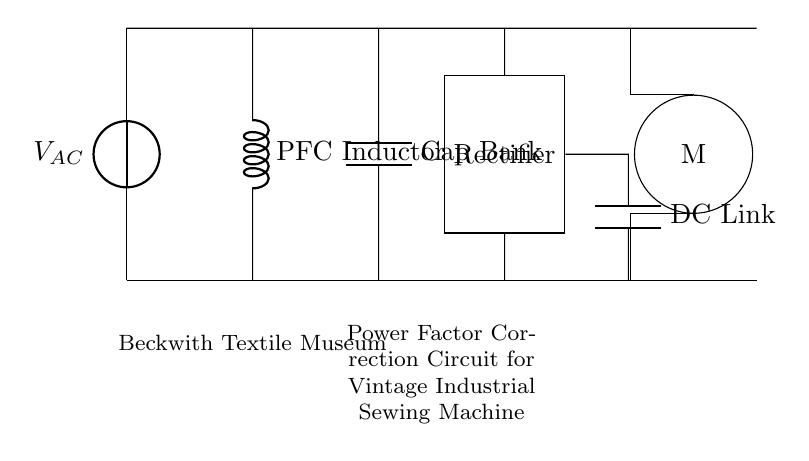What type of power source is used in the circuit? The circuit uses an alternating current power source, as indicated by the voltage source labeled VAC.
Answer: alternating current What does the abbreviation PFC stand for in the circuit? PFC stands for Power Factor Correction, referring to the inductor in the circuit designed to improve the power factor.
Answer: Power Factor Correction How many main components are there in the circuit? The circuit has four main components: a PFC inductor, a capacitor bank, a rectifier, and a motor.
Answer: four What is the role of the capacitor bank in this circuit? The capacitor bank provides reactive power to improve the circuit's power factor and stabilize voltage fluctuations.
Answer: improve power factor What is the main function of the rectifier in this circuit? The rectifier converts alternating current from the power source into direct current for the motor to function properly.
Answer: convert AC to DC How does the PFC inductor affect the overall circuit performance? The PFC inductor reduces the phase difference between voltage and current, thus improving the overall efficiency and performance of the circuit.
Answer: improves efficiency What is the purpose of the DC Link capacitor in the circuit? The DC Link capacitor smooths and filters the rectified voltage, ensuring a more stable direct current supply to the motor.
Answer: smooths voltage 